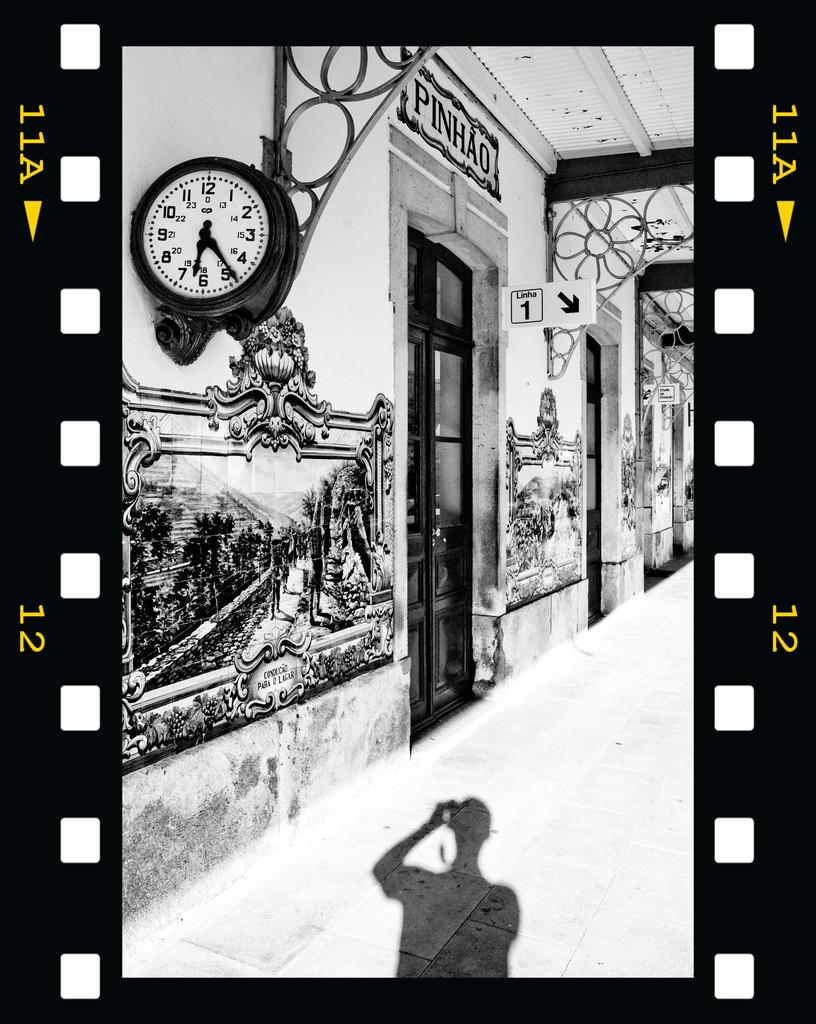<image>
Relay a brief, clear account of the picture shown. A sign painted above the doorway read "Pinhao". 